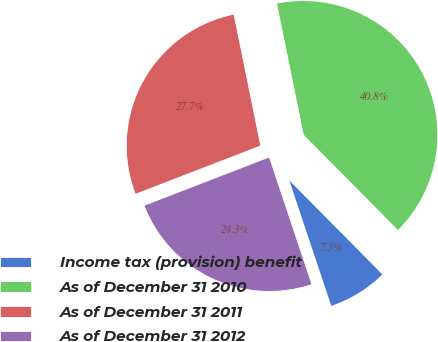Convert chart to OTSL. <chart><loc_0><loc_0><loc_500><loc_500><pie_chart><fcel>Income tax (provision) benefit<fcel>As of December 31 2010<fcel>As of December 31 2011<fcel>As of December 31 2012<nl><fcel>7.28%<fcel>40.78%<fcel>27.67%<fcel>24.27%<nl></chart> 